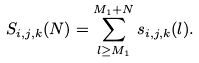<formula> <loc_0><loc_0><loc_500><loc_500>S _ { i , j , k } ( N ) = \sum _ { l \geq M _ { 1 } } ^ { M _ { 1 } + N } s _ { i , j , k } ( l ) .</formula> 